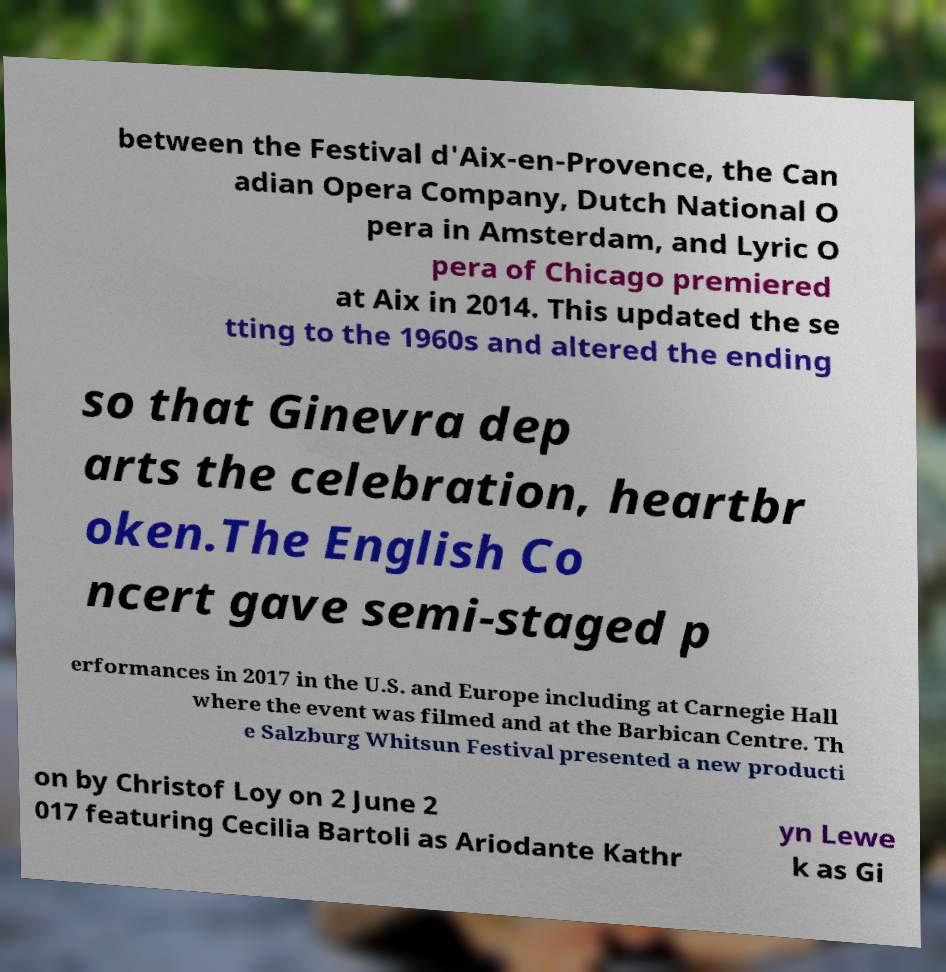Can you read and provide the text displayed in the image?This photo seems to have some interesting text. Can you extract and type it out for me? between the Festival d'Aix-en-Provence, the Can adian Opera Company, Dutch National O pera in Amsterdam, and Lyric O pera of Chicago premiered at Aix in 2014. This updated the se tting to the 1960s and altered the ending so that Ginevra dep arts the celebration, heartbr oken.The English Co ncert gave semi-staged p erformances in 2017 in the U.S. and Europe including at Carnegie Hall where the event was filmed and at the Barbican Centre. Th e Salzburg Whitsun Festival presented a new producti on by Christof Loy on 2 June 2 017 featuring Cecilia Bartoli as Ariodante Kathr yn Lewe k as Gi 